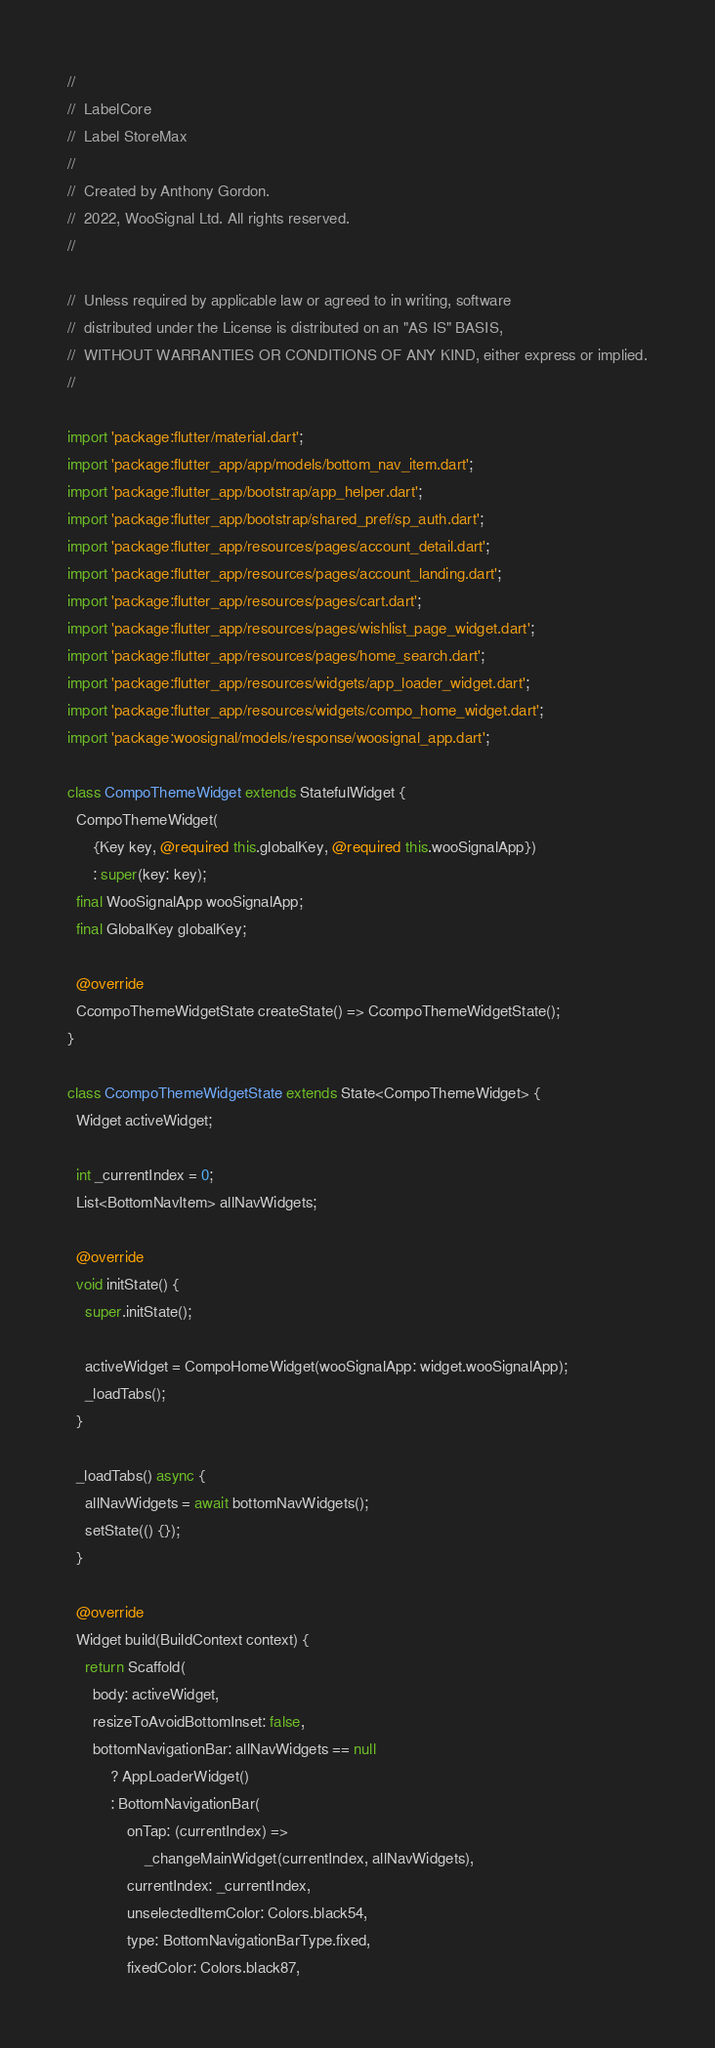Convert code to text. <code><loc_0><loc_0><loc_500><loc_500><_Dart_>//
//  LabelCore
//  Label StoreMax
//
//  Created by Anthony Gordon.
//  2022, WooSignal Ltd. All rights reserved.
//

//  Unless required by applicable law or agreed to in writing, software
//  distributed under the License is distributed on an "AS IS" BASIS,
//  WITHOUT WARRANTIES OR CONDITIONS OF ANY KIND, either express or implied.
//

import 'package:flutter/material.dart';
import 'package:flutter_app/app/models/bottom_nav_item.dart';
import 'package:flutter_app/bootstrap/app_helper.dart';
import 'package:flutter_app/bootstrap/shared_pref/sp_auth.dart';
import 'package:flutter_app/resources/pages/account_detail.dart';
import 'package:flutter_app/resources/pages/account_landing.dart';
import 'package:flutter_app/resources/pages/cart.dart';
import 'package:flutter_app/resources/pages/wishlist_page_widget.dart';
import 'package:flutter_app/resources/pages/home_search.dart';
import 'package:flutter_app/resources/widgets/app_loader_widget.dart';
import 'package:flutter_app/resources/widgets/compo_home_widget.dart';
import 'package:woosignal/models/response/woosignal_app.dart';

class CompoThemeWidget extends StatefulWidget {
  CompoThemeWidget(
      {Key key, @required this.globalKey, @required this.wooSignalApp})
      : super(key: key);
  final WooSignalApp wooSignalApp;
  final GlobalKey globalKey;

  @override
  CcompoThemeWidgetState createState() => CcompoThemeWidgetState();
}

class CcompoThemeWidgetState extends State<CompoThemeWidget> {
  Widget activeWidget;

  int _currentIndex = 0;
  List<BottomNavItem> allNavWidgets;

  @override
  void initState() {
    super.initState();

    activeWidget = CompoHomeWidget(wooSignalApp: widget.wooSignalApp);
    _loadTabs();
  }

  _loadTabs() async {
    allNavWidgets = await bottomNavWidgets();
    setState(() {});
  }

  @override
  Widget build(BuildContext context) {
    return Scaffold(
      body: activeWidget,
      resizeToAvoidBottomInset: false,
      bottomNavigationBar: allNavWidgets == null
          ? AppLoaderWidget()
          : BottomNavigationBar(
              onTap: (currentIndex) =>
                  _changeMainWidget(currentIndex, allNavWidgets),
              currentIndex: _currentIndex,
              unselectedItemColor: Colors.black54,
              type: BottomNavigationBarType.fixed,
              fixedColor: Colors.black87,</code> 